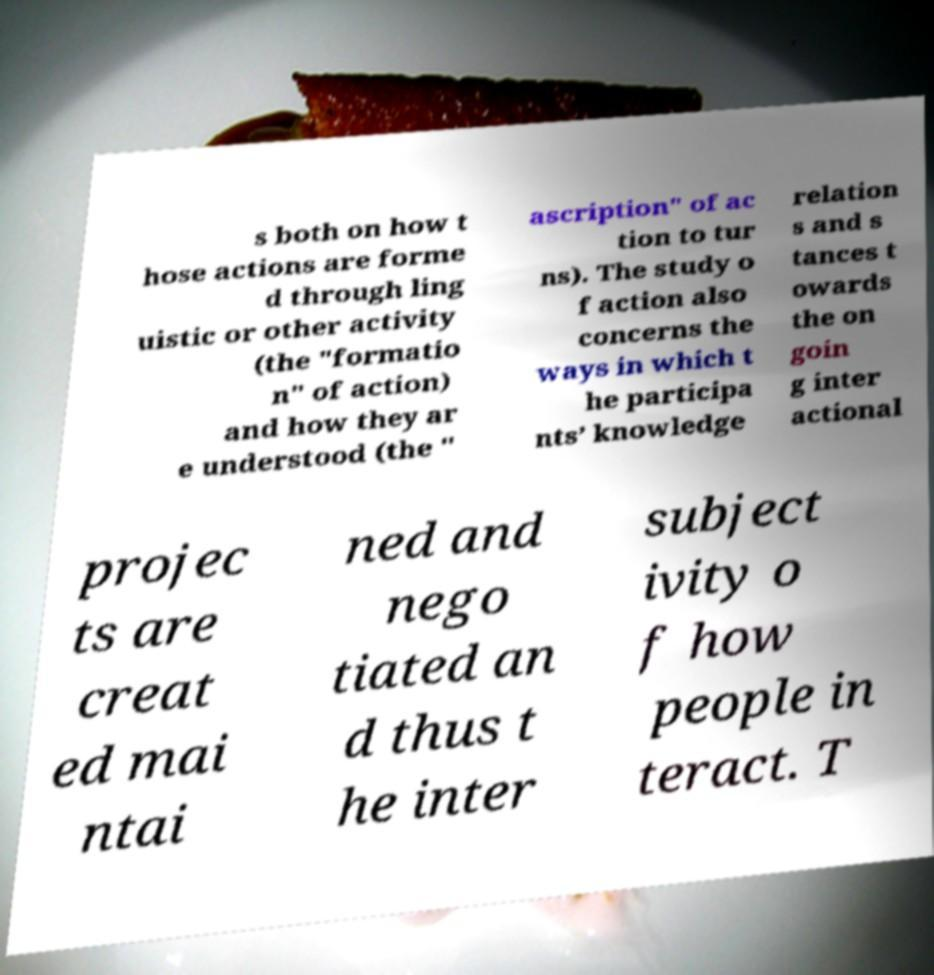Can you read and provide the text displayed in the image?This photo seems to have some interesting text. Can you extract and type it out for me? s both on how t hose actions are forme d through ling uistic or other activity (the "formatio n" of action) and how they ar e understood (the " ascription" of ac tion to tur ns). The study o f action also concerns the ways in which t he participa nts’ knowledge relation s and s tances t owards the on goin g inter actional projec ts are creat ed mai ntai ned and nego tiated an d thus t he inter subject ivity o f how people in teract. T 